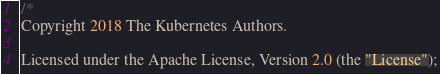Convert code to text. <code><loc_0><loc_0><loc_500><loc_500><_Go_>/*
Copyright 2018 The Kubernetes Authors.

Licensed under the Apache License, Version 2.0 (the "License");</code> 